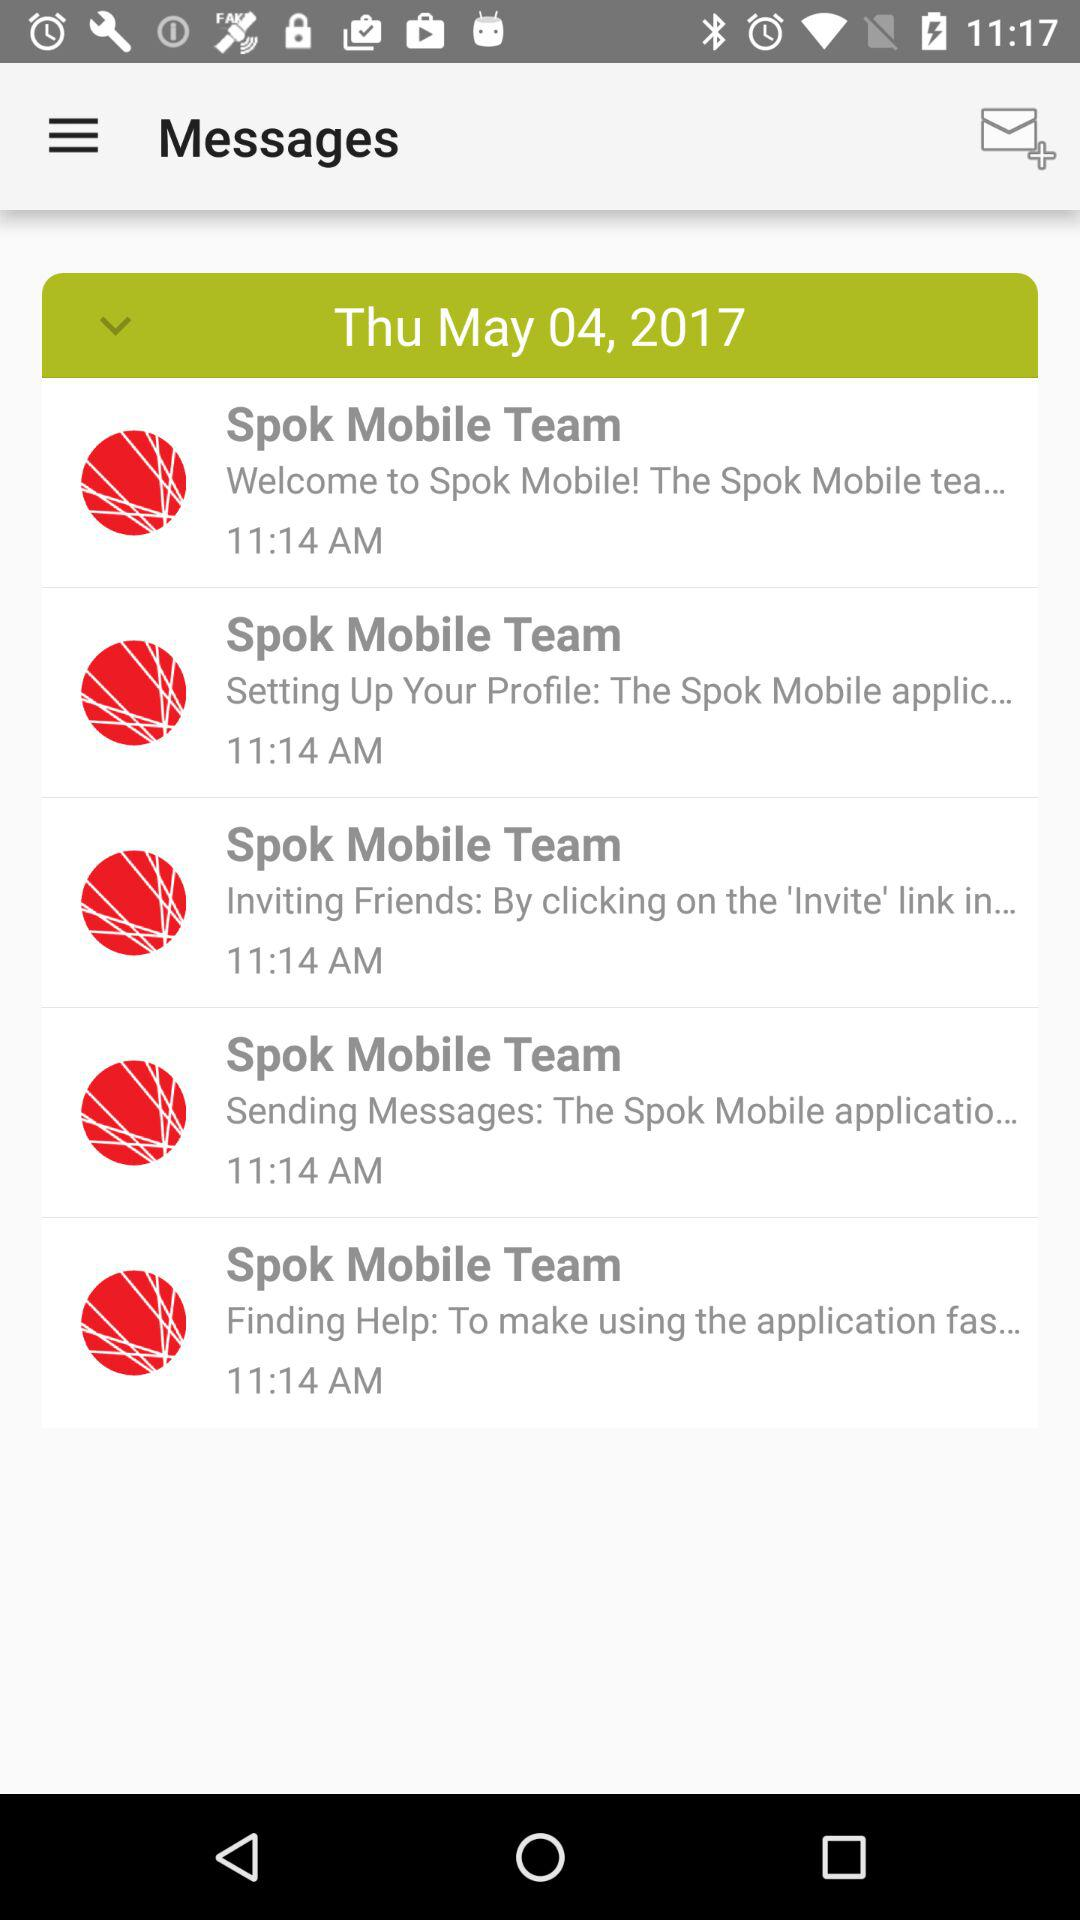What day is it on the selected date? The day is Thursday. 